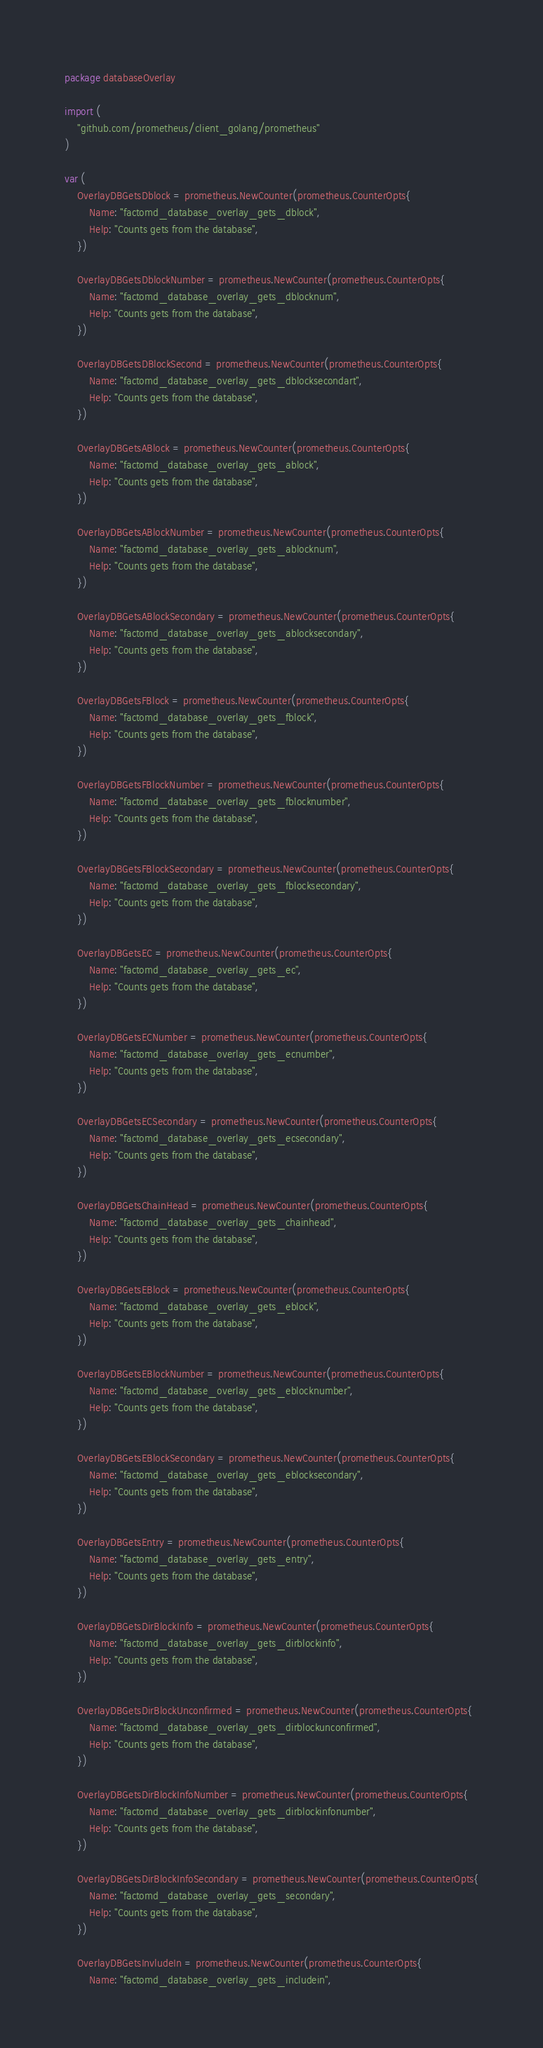<code> <loc_0><loc_0><loc_500><loc_500><_Go_>package databaseOverlay

import (
	"github.com/prometheus/client_golang/prometheus"
)

var (
	OverlayDBGetsDblock = prometheus.NewCounter(prometheus.CounterOpts{
		Name: "factomd_database_overlay_gets_dblock",
		Help: "Counts gets from the database",
	})

	OverlayDBGetsDblockNumber = prometheus.NewCounter(prometheus.CounterOpts{
		Name: "factomd_database_overlay_gets_dblocknum",
		Help: "Counts gets from the database",
	})

	OverlayDBGetsDBlockSecond = prometheus.NewCounter(prometheus.CounterOpts{
		Name: "factomd_database_overlay_gets_dblocksecondart",
		Help: "Counts gets from the database",
	})

	OverlayDBGetsABlock = prometheus.NewCounter(prometheus.CounterOpts{
		Name: "factomd_database_overlay_gets_ablock",
		Help: "Counts gets from the database",
	})

	OverlayDBGetsABlockNumber = prometheus.NewCounter(prometheus.CounterOpts{
		Name: "factomd_database_overlay_gets_ablocknum",
		Help: "Counts gets from the database",
	})

	OverlayDBGetsABlockSecondary = prometheus.NewCounter(prometheus.CounterOpts{
		Name: "factomd_database_overlay_gets_ablocksecondary",
		Help: "Counts gets from the database",
	})

	OverlayDBGetsFBlock = prometheus.NewCounter(prometheus.CounterOpts{
		Name: "factomd_database_overlay_gets_fblock",
		Help: "Counts gets from the database",
	})

	OverlayDBGetsFBlockNumber = prometheus.NewCounter(prometheus.CounterOpts{
		Name: "factomd_database_overlay_gets_fblocknumber",
		Help: "Counts gets from the database",
	})

	OverlayDBGetsFBlockSecondary = prometheus.NewCounter(prometheus.CounterOpts{
		Name: "factomd_database_overlay_gets_fblocksecondary",
		Help: "Counts gets from the database",
	})

	OverlayDBGetsEC = prometheus.NewCounter(prometheus.CounterOpts{
		Name: "factomd_database_overlay_gets_ec",
		Help: "Counts gets from the database",
	})

	OverlayDBGetsECNumber = prometheus.NewCounter(prometheus.CounterOpts{
		Name: "factomd_database_overlay_gets_ecnumber",
		Help: "Counts gets from the database",
	})

	OverlayDBGetsECSecondary = prometheus.NewCounter(prometheus.CounterOpts{
		Name: "factomd_database_overlay_gets_ecsecondary",
		Help: "Counts gets from the database",
	})

	OverlayDBGetsChainHead = prometheus.NewCounter(prometheus.CounterOpts{
		Name: "factomd_database_overlay_gets_chainhead",
		Help: "Counts gets from the database",
	})

	OverlayDBGetsEBlock = prometheus.NewCounter(prometheus.CounterOpts{
		Name: "factomd_database_overlay_gets_eblock",
		Help: "Counts gets from the database",
	})

	OverlayDBGetsEBlockNumber = prometheus.NewCounter(prometheus.CounterOpts{
		Name: "factomd_database_overlay_gets_eblocknumber",
		Help: "Counts gets from the database",
	})

	OverlayDBGetsEBlockSecondary = prometheus.NewCounter(prometheus.CounterOpts{
		Name: "factomd_database_overlay_gets_eblocksecondary",
		Help: "Counts gets from the database",
	})

	OverlayDBGetsEntry = prometheus.NewCounter(prometheus.CounterOpts{
		Name: "factomd_database_overlay_gets_entry",
		Help: "Counts gets from the database",
	})

	OverlayDBGetsDirBlockInfo = prometheus.NewCounter(prometheus.CounterOpts{
		Name: "factomd_database_overlay_gets_dirblockinfo",
		Help: "Counts gets from the database",
	})

	OverlayDBGetsDirBlockUnconfirmed = prometheus.NewCounter(prometheus.CounterOpts{
		Name: "factomd_database_overlay_gets_dirblockunconfirmed",
		Help: "Counts gets from the database",
	})

	OverlayDBGetsDirBlockInfoNumber = prometheus.NewCounter(prometheus.CounterOpts{
		Name: "factomd_database_overlay_gets_dirblockinfonumber",
		Help: "Counts gets from the database",
	})

	OverlayDBGetsDirBlockInfoSecondary = prometheus.NewCounter(prometheus.CounterOpts{
		Name: "factomd_database_overlay_gets_secondary",
		Help: "Counts gets from the database",
	})

	OverlayDBGetsInvludeIn = prometheus.NewCounter(prometheus.CounterOpts{
		Name: "factomd_database_overlay_gets_includein",</code> 